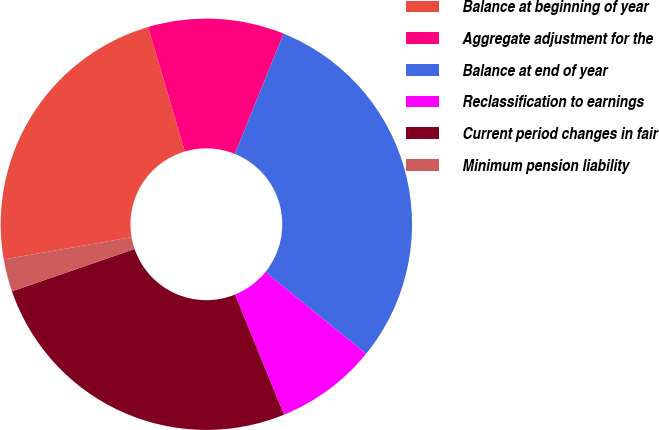Convert chart. <chart><loc_0><loc_0><loc_500><loc_500><pie_chart><fcel>Balance at beginning of year<fcel>Aggregate adjustment for the<fcel>Balance at end of year<fcel>Reclassification to earnings<fcel>Current period changes in fair<fcel>Minimum pension liability<nl><fcel>23.16%<fcel>10.7%<fcel>29.72%<fcel>7.99%<fcel>25.88%<fcel>2.55%<nl></chart> 